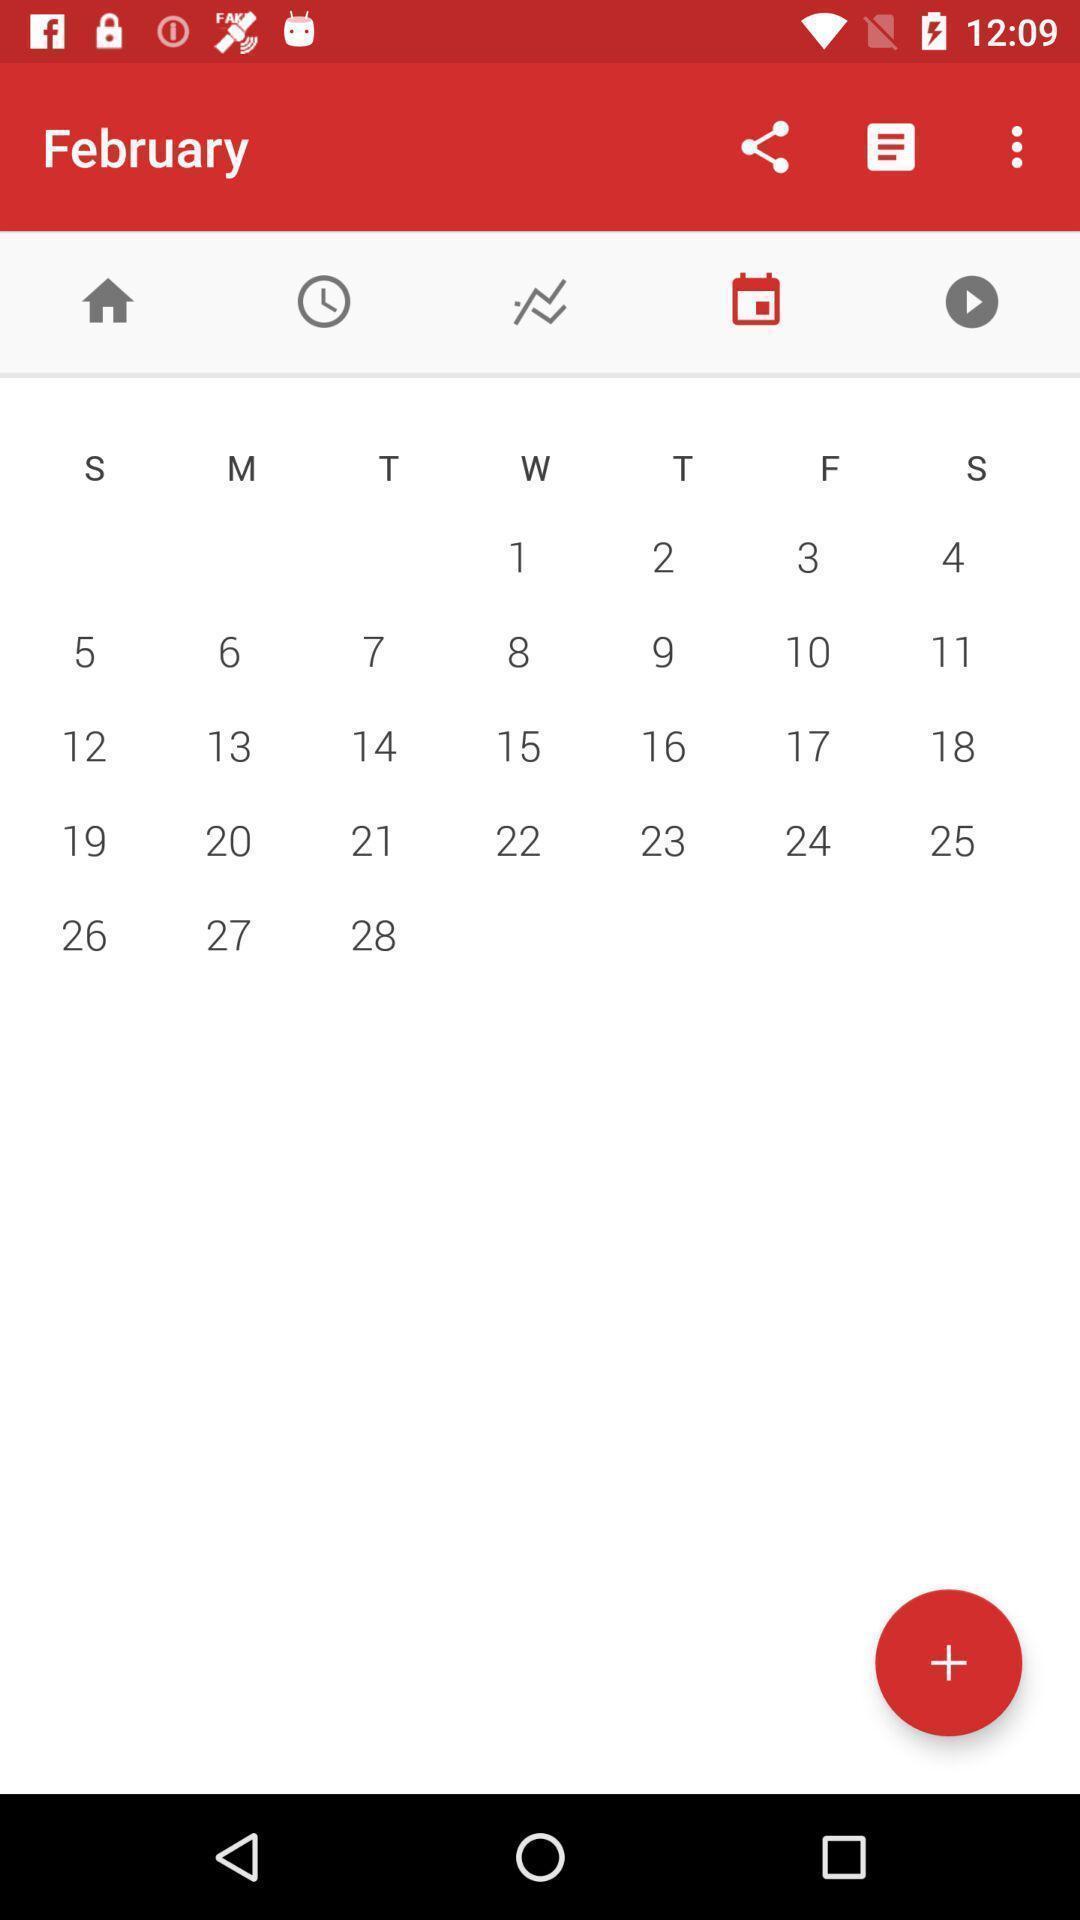Explain what's happening in this screen capture. Window displaying a calendar page. 